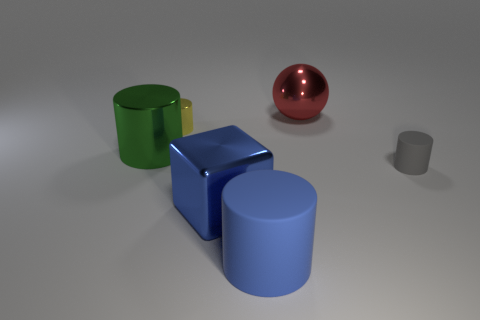What number of big shiny cubes are the same color as the big rubber thing?
Keep it short and to the point. 1. There is a object that is the same color as the large matte cylinder; what is its material?
Your answer should be compact. Metal. Do the small yellow cylinder and the green object have the same material?
Your answer should be compact. Yes. What number of objects are large brown spheres or big shiny balls?
Your answer should be very brief. 1. What shape is the large metallic thing that is right of the blue rubber cylinder?
Your answer should be compact. Sphere. There is a tiny cylinder that is made of the same material as the big red object; what is its color?
Make the answer very short. Yellow. What material is the small gray object that is the same shape as the large green metallic thing?
Make the answer very short. Rubber. What is the shape of the green thing?
Give a very brief answer. Cylinder. What is the cylinder that is on the left side of the large red metal sphere and in front of the large green object made of?
Ensure brevity in your answer.  Rubber. What is the shape of the yellow object that is the same material as the large green cylinder?
Ensure brevity in your answer.  Cylinder. 